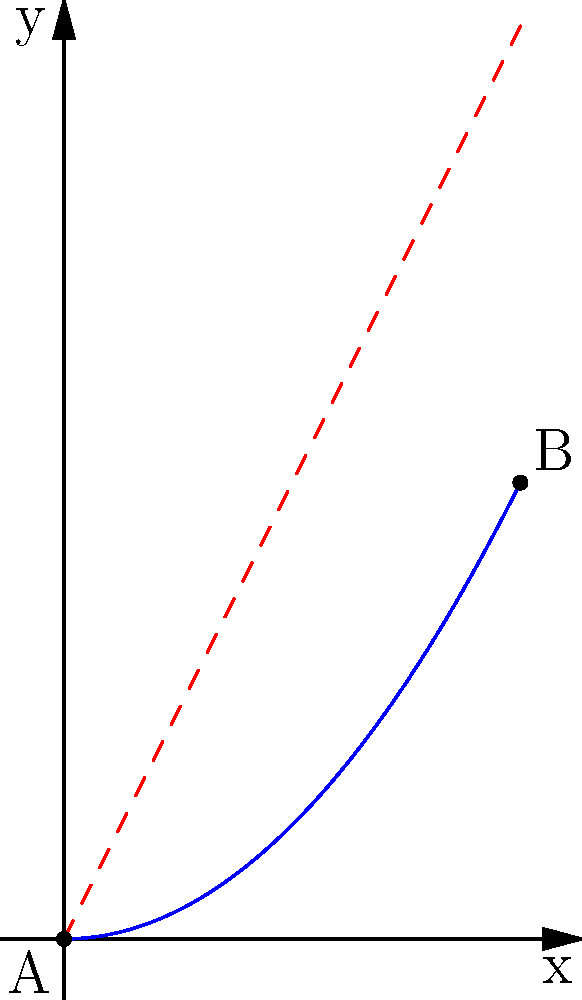In your miniature wargaming setup, you need to design a ramp for a small vehicle to achieve maximum speed. The ramp starts at point A(0,0) and ends at point B(1,1). Which curve would provide the fastest descent for the miniature vehicle, and how would you calculate it using calculus? To find the optimal curve for the fastest descent, we need to use the brachistochrone problem from calculus of variations. Here's the step-by-step solution:

1) The brachistochrone curve is the solution to this problem, which is a cycloid.

2) The parametric equations for a cycloid are:
   $$x = a(\theta - \sin\theta)$$
   $$y = a(1 - \cos\theta)$$
   where $a$ is a constant and $0 \leq \theta \leq 2\pi$.

3) We need to fit this curve to our endpoints A(0,0) and B(1,1). At B(1,1), we have:
   $$1 = a(\theta - \sin\theta)$$
   $$1 = a(1 - \cos\theta)$$

4) Dividing these equations:
   $$\frac{1}{1} = \frac{\theta - \sin\theta}{1 - \cos\theta}$$

5) This transcendental equation can be solved numerically to find $\theta \approx 4.49341$. 

6) Substituting this back into either equation gives $a \approx 0.32423$.

7) Therefore, the optimal curve is a cycloid with parametric equations:
   $$x = 0.32423(\theta - \sin\theta)$$
   $$y = 0.32423(1 - \cos\theta)$$
   where $0 \leq \theta \leq 4.49341$.

This curve will provide the fastest descent for your miniature vehicle, outperforming a straight line or any other curve between the two points.
Answer: Cycloid with equations $x = 0.32423(\theta - \sin\theta)$, $y = 0.32423(1 - \cos\theta)$, $0 \leq \theta \leq 4.49341$ 